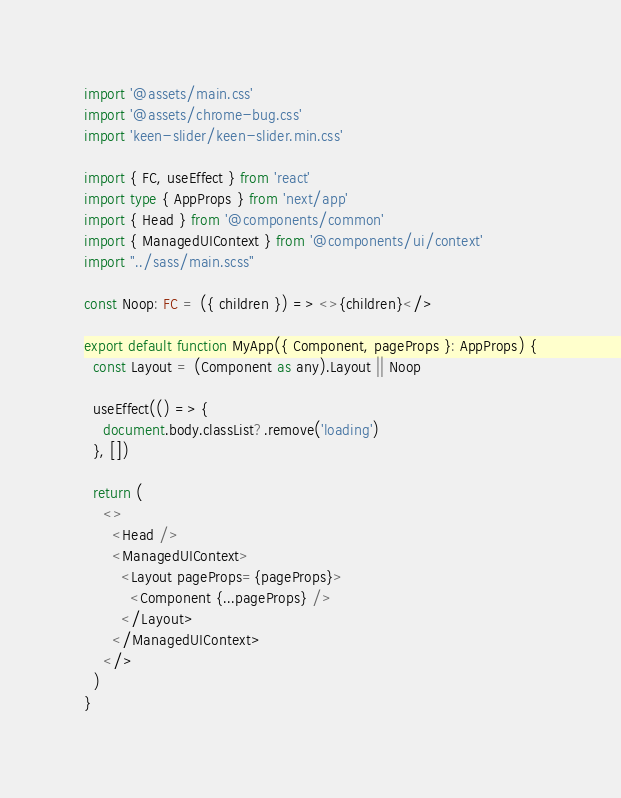<code> <loc_0><loc_0><loc_500><loc_500><_TypeScript_>import '@assets/main.css'
import '@assets/chrome-bug.css'
import 'keen-slider/keen-slider.min.css'

import { FC, useEffect } from 'react'
import type { AppProps } from 'next/app'
import { Head } from '@components/common'
import { ManagedUIContext } from '@components/ui/context'
import "../sass/main.scss"

const Noop: FC = ({ children }) => <>{children}</>

export default function MyApp({ Component, pageProps }: AppProps) {
  const Layout = (Component as any).Layout || Noop

  useEffect(() => {
    document.body.classList?.remove('loading')
  }, [])

  return (
    <>
      <Head />
      <ManagedUIContext>
        <Layout pageProps={pageProps}>
          <Component {...pageProps} />
        </Layout>
      </ManagedUIContext>
    </>
  )
}
</code> 